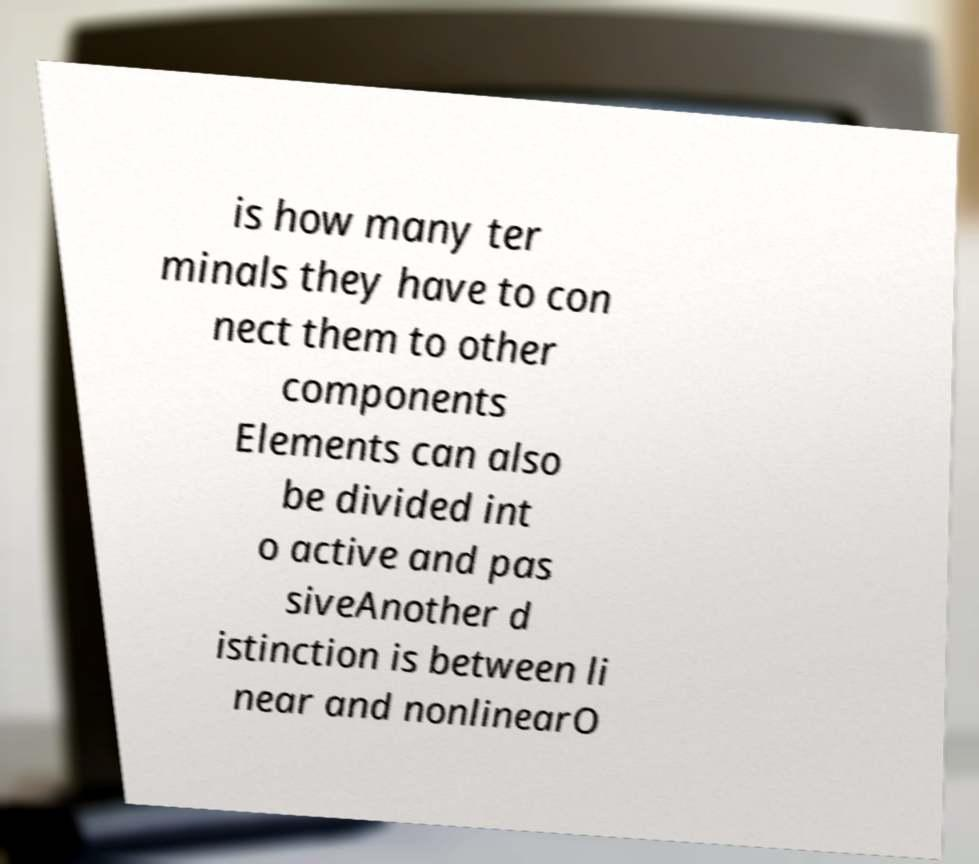Can you accurately transcribe the text from the provided image for me? is how many ter minals they have to con nect them to other components Elements can also be divided int o active and pas siveAnother d istinction is between li near and nonlinearO 